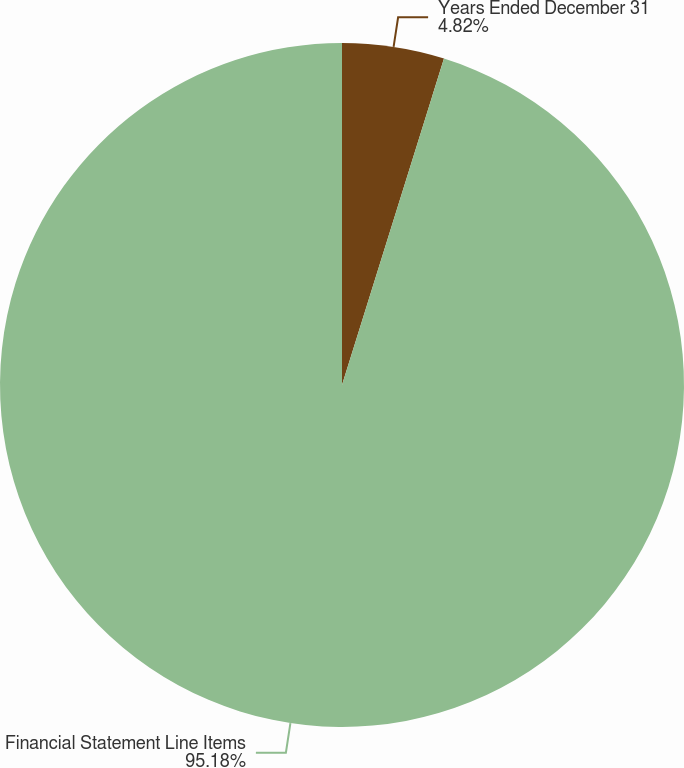<chart> <loc_0><loc_0><loc_500><loc_500><pie_chart><fcel>Years Ended December 31<fcel>Financial Statement Line Items<nl><fcel>4.82%<fcel>95.18%<nl></chart> 